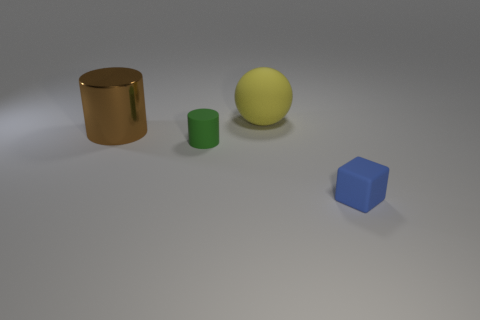Add 2 tiny blue objects. How many objects exist? 6 Subtract all cubes. How many objects are left? 3 Add 4 small objects. How many small objects are left? 6 Add 1 large blue cylinders. How many large blue cylinders exist? 1 Subtract all brown cylinders. How many cylinders are left? 1 Subtract 0 gray spheres. How many objects are left? 4 Subtract 1 blocks. How many blocks are left? 0 Subtract all cyan cubes. Subtract all red balls. How many cubes are left? 1 Subtract all purple cylinders. How many purple blocks are left? 0 Subtract all tiny yellow things. Subtract all small matte cubes. How many objects are left? 3 